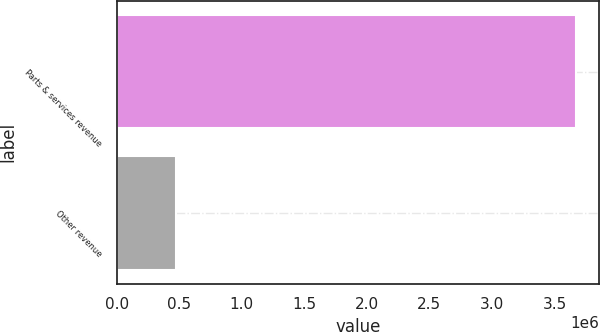Convert chart to OTSL. <chart><loc_0><loc_0><loc_500><loc_500><bar_chart><fcel>Parts & services revenue<fcel>Other revenue<nl><fcel>3.6716e+06<fcel>474403<nl></chart> 